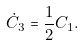Convert formula to latex. <formula><loc_0><loc_0><loc_500><loc_500>\dot { C } _ { 3 } = \frac { 1 } { 2 } C _ { 1 } .</formula> 